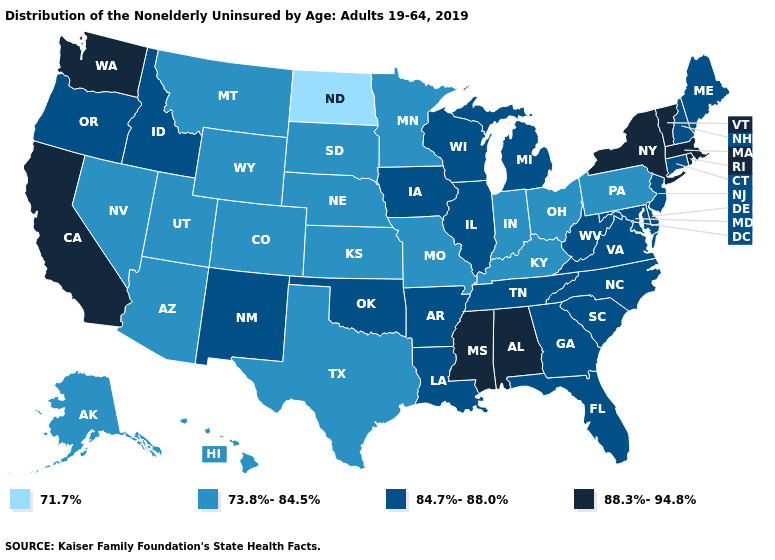What is the highest value in the West ?
Short answer required. 88.3%-94.8%. Which states have the lowest value in the USA?
Keep it brief. North Dakota. What is the value of Virginia?
Short answer required. 84.7%-88.0%. Does Vermont have the highest value in the Northeast?
Short answer required. Yes. Does the map have missing data?
Quick response, please. No. Which states have the lowest value in the USA?
Answer briefly. North Dakota. Name the states that have a value in the range 84.7%-88.0%?
Keep it brief. Arkansas, Connecticut, Delaware, Florida, Georgia, Idaho, Illinois, Iowa, Louisiana, Maine, Maryland, Michigan, New Hampshire, New Jersey, New Mexico, North Carolina, Oklahoma, Oregon, South Carolina, Tennessee, Virginia, West Virginia, Wisconsin. Name the states that have a value in the range 73.8%-84.5%?
Answer briefly. Alaska, Arizona, Colorado, Hawaii, Indiana, Kansas, Kentucky, Minnesota, Missouri, Montana, Nebraska, Nevada, Ohio, Pennsylvania, South Dakota, Texas, Utah, Wyoming. Which states have the highest value in the USA?
Be succinct. Alabama, California, Massachusetts, Mississippi, New York, Rhode Island, Vermont, Washington. Which states have the lowest value in the South?
Give a very brief answer. Kentucky, Texas. Does Washington have the lowest value in the West?
Be succinct. No. Does Oklahoma have a lower value than Arkansas?
Write a very short answer. No. Name the states that have a value in the range 84.7%-88.0%?
Keep it brief. Arkansas, Connecticut, Delaware, Florida, Georgia, Idaho, Illinois, Iowa, Louisiana, Maine, Maryland, Michigan, New Hampshire, New Jersey, New Mexico, North Carolina, Oklahoma, Oregon, South Carolina, Tennessee, Virginia, West Virginia, Wisconsin. What is the value of Illinois?
Keep it brief. 84.7%-88.0%. Does Washington have a higher value than Alaska?
Keep it brief. Yes. 